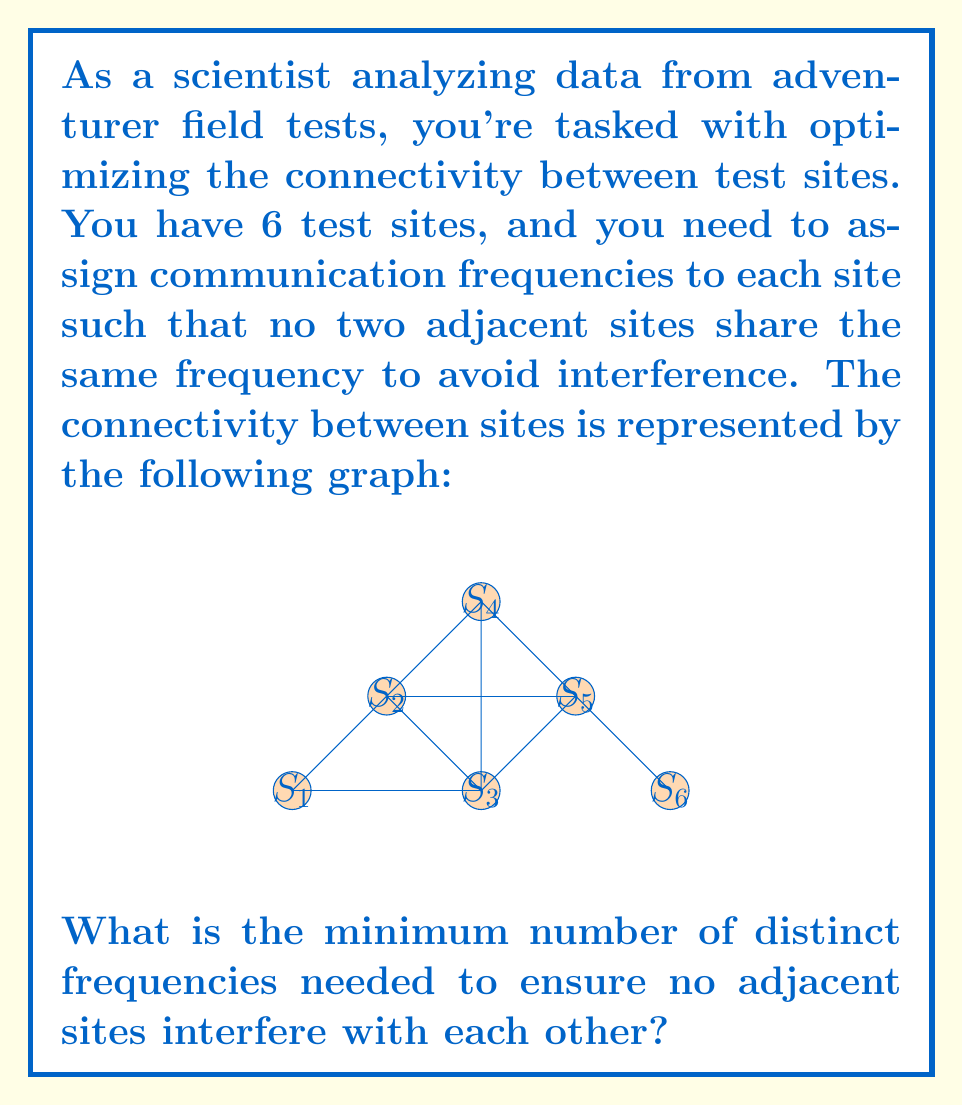Solve this math problem. To solve this problem, we need to use the concept of graph coloring, where each color represents a distinct frequency.

1) First, we analyze the graph:
   - There are 6 vertices (sites) and 9 edges (connections).
   - The graph is planar but not complete.

2) We can use the greedy coloring algorithm to find a valid coloring:
   - Start with site S1 and assign it color 1.
   - For each subsequent site, assign the lowest-numbered color that hasn't been used by its neighbors.

3) Following this process:
   - S1: Color 1
   - S2: Color 2 (adjacent to S1)
   - S3: Color 2 (adjacent to S1, not S2)
   - S4: Color 3 (adjacent to S2 and S3)
   - S5: Color 1 (adjacent to S2, S3, S4)
   - S6: Color 2 (adjacent to S5)

4) We've used 3 colors in total, which means we need a minimum of 3 distinct frequencies.

5) To verify this is optimal:
   - The subgraph formed by S2, S3, and S4 is a triangle, which requires 3 colors.
   - Therefore, no 2-coloring is possible for the entire graph.

Thus, the minimum number of frequencies needed is 3.
Answer: 3 